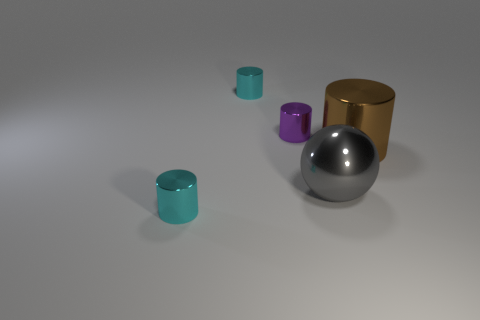Can you describe the shapes and colors in this image? Certainly! The image shows a collection of geometric shapes including a large silver sphere, a medium-sized golden cylinder, and three smaller cylinders in teal, purple, and aquamarine. These shapes are set against a neutral grey background which casts soft shadows beneath each object. 